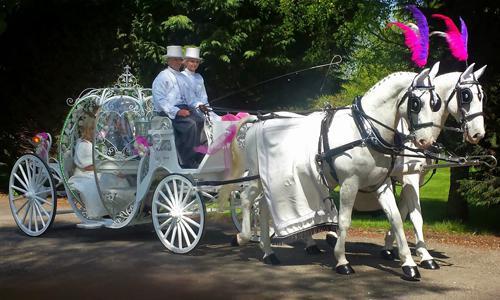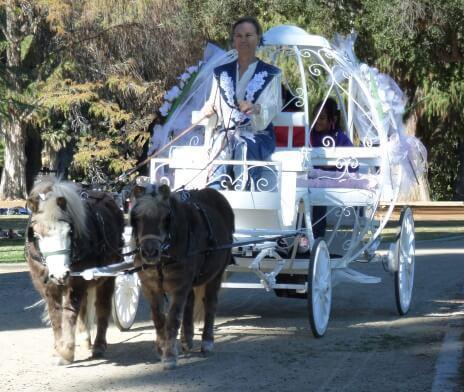The first image is the image on the left, the second image is the image on the right. For the images displayed, is the sentence "In at least one image there are two white horses pulling a white pumpkin carriage." factually correct? Answer yes or no. Yes. The first image is the image on the left, the second image is the image on the right. For the images displayed, is the sentence "there are white horses with tassels on the top of their heads pulling a cinderella type princess carriage" factually correct? Answer yes or no. Yes. 